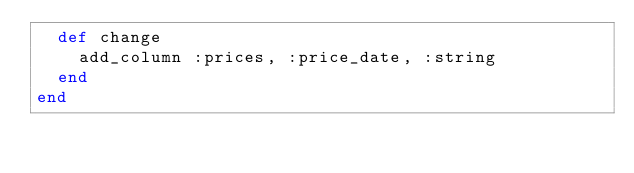Convert code to text. <code><loc_0><loc_0><loc_500><loc_500><_Ruby_>  def change
    add_column :prices, :price_date, :string
  end
end
</code> 